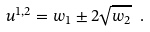Convert formula to latex. <formula><loc_0><loc_0><loc_500><loc_500>u ^ { 1 , 2 } = w _ { 1 } \pm 2 { \sqrt { w _ { 2 } } } \ .</formula> 